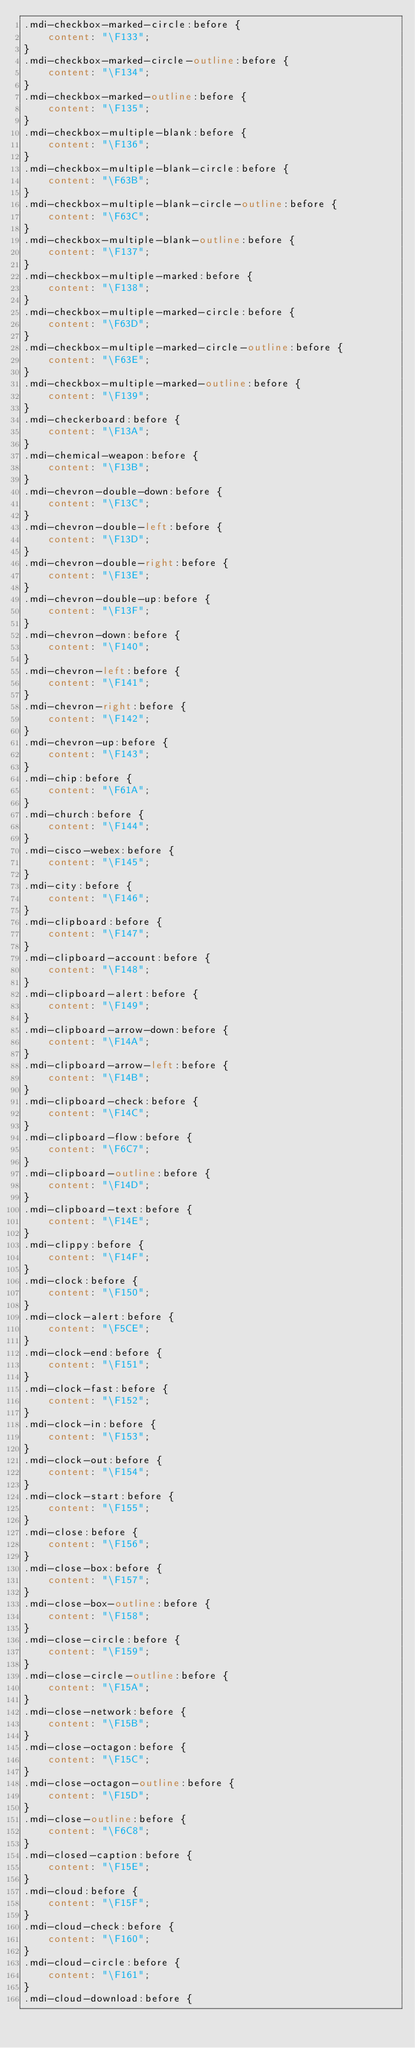<code> <loc_0><loc_0><loc_500><loc_500><_CSS_>.mdi-checkbox-marked-circle:before {
    content: "\F133";
}
.mdi-checkbox-marked-circle-outline:before {
    content: "\F134";
}
.mdi-checkbox-marked-outline:before {
    content: "\F135";
}
.mdi-checkbox-multiple-blank:before {
    content: "\F136";
}
.mdi-checkbox-multiple-blank-circle:before {
    content: "\F63B";
}
.mdi-checkbox-multiple-blank-circle-outline:before {
    content: "\F63C";
}
.mdi-checkbox-multiple-blank-outline:before {
    content: "\F137";
}
.mdi-checkbox-multiple-marked:before {
    content: "\F138";
}
.mdi-checkbox-multiple-marked-circle:before {
    content: "\F63D";
}
.mdi-checkbox-multiple-marked-circle-outline:before {
    content: "\F63E";
}
.mdi-checkbox-multiple-marked-outline:before {
    content: "\F139";
}
.mdi-checkerboard:before {
    content: "\F13A";
}
.mdi-chemical-weapon:before {
    content: "\F13B";
}
.mdi-chevron-double-down:before {
    content: "\F13C";
}
.mdi-chevron-double-left:before {
    content: "\F13D";
}
.mdi-chevron-double-right:before {
    content: "\F13E";
}
.mdi-chevron-double-up:before {
    content: "\F13F";
}
.mdi-chevron-down:before {
    content: "\F140";
}
.mdi-chevron-left:before {
    content: "\F141";
}
.mdi-chevron-right:before {
    content: "\F142";
}
.mdi-chevron-up:before {
    content: "\F143";
}
.mdi-chip:before {
    content: "\F61A";
}
.mdi-church:before {
    content: "\F144";
}
.mdi-cisco-webex:before {
    content: "\F145";
}
.mdi-city:before {
    content: "\F146";
}
.mdi-clipboard:before {
    content: "\F147";
}
.mdi-clipboard-account:before {
    content: "\F148";
}
.mdi-clipboard-alert:before {
    content: "\F149";
}
.mdi-clipboard-arrow-down:before {
    content: "\F14A";
}
.mdi-clipboard-arrow-left:before {
    content: "\F14B";
}
.mdi-clipboard-check:before {
    content: "\F14C";
}
.mdi-clipboard-flow:before {
    content: "\F6C7";
}
.mdi-clipboard-outline:before {
    content: "\F14D";
}
.mdi-clipboard-text:before {
    content: "\F14E";
}
.mdi-clippy:before {
    content: "\F14F";
}
.mdi-clock:before {
    content: "\F150";
}
.mdi-clock-alert:before {
    content: "\F5CE";
}
.mdi-clock-end:before {
    content: "\F151";
}
.mdi-clock-fast:before {
    content: "\F152";
}
.mdi-clock-in:before {
    content: "\F153";
}
.mdi-clock-out:before {
    content: "\F154";
}
.mdi-clock-start:before {
    content: "\F155";
}
.mdi-close:before {
    content: "\F156";
}
.mdi-close-box:before {
    content: "\F157";
}
.mdi-close-box-outline:before {
    content: "\F158";
}
.mdi-close-circle:before {
    content: "\F159";
}
.mdi-close-circle-outline:before {
    content: "\F15A";
}
.mdi-close-network:before {
    content: "\F15B";
}
.mdi-close-octagon:before {
    content: "\F15C";
}
.mdi-close-octagon-outline:before {
    content: "\F15D";
}
.mdi-close-outline:before {
    content: "\F6C8";
}
.mdi-closed-caption:before {
    content: "\F15E";
}
.mdi-cloud:before {
    content: "\F15F";
}
.mdi-cloud-check:before {
    content: "\F160";
}
.mdi-cloud-circle:before {
    content: "\F161";
}
.mdi-cloud-download:before {</code> 